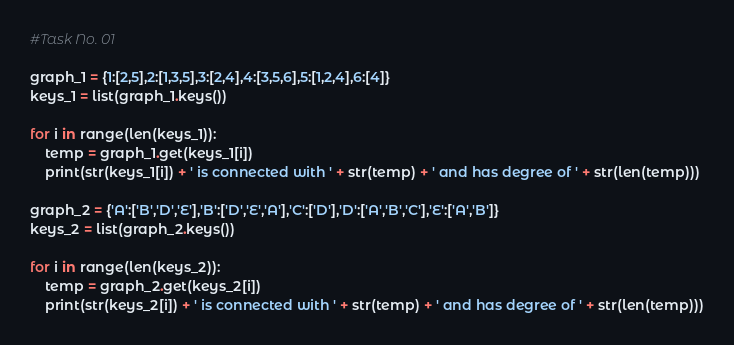Convert code to text. <code><loc_0><loc_0><loc_500><loc_500><_Python_>#Task No. 01

graph_1 = {1:[2,5],2:[1,3,5],3:[2,4],4:[3,5,6],5:[1,2,4],6:[4]}
keys_1 = list(graph_1.keys())

for i in range(len(keys_1)):
    temp = graph_1.get(keys_1[i])
    print(str(keys_1[i]) + ' is connected with ' + str(temp) + ' and has degree of ' + str(len(temp)))

graph_2 = {'A':['B','D','E'],'B':['D','E','A'],'C':['D'],'D':['A','B','C'],'E':['A','B']}
keys_2 = list(graph_2.keys())

for i in range(len(keys_2)):
    temp = graph_2.get(keys_2[i])
    print(str(keys_2[i]) + ' is connected with ' + str(temp) + ' and has degree of ' + str(len(temp)))
</code> 